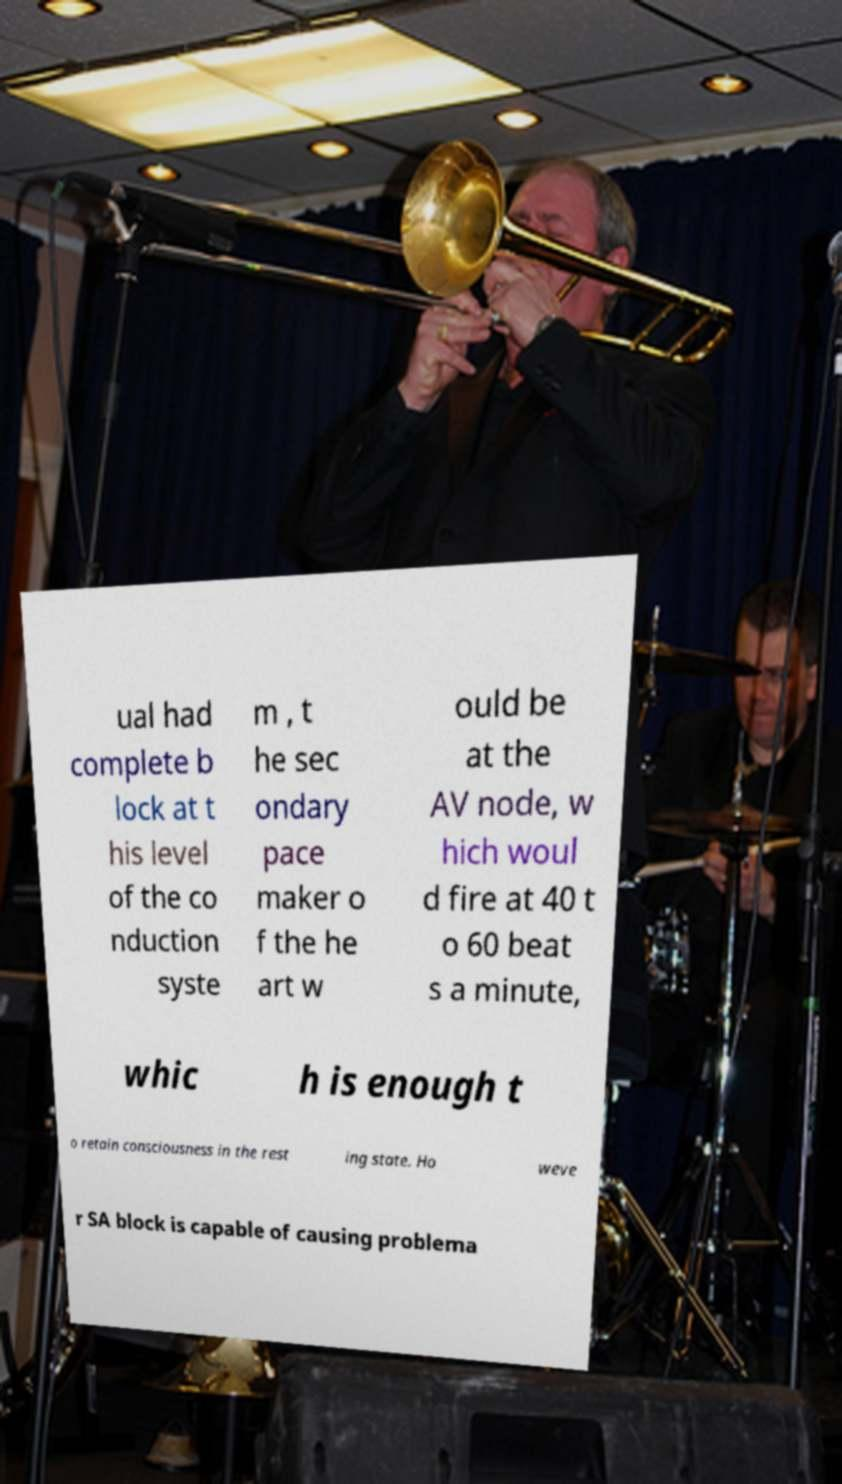Please identify and transcribe the text found in this image. ual had complete b lock at t his level of the co nduction syste m , t he sec ondary pace maker o f the he art w ould be at the AV node, w hich woul d fire at 40 t o 60 beat s a minute, whic h is enough t o retain consciousness in the rest ing state. Ho weve r SA block is capable of causing problema 